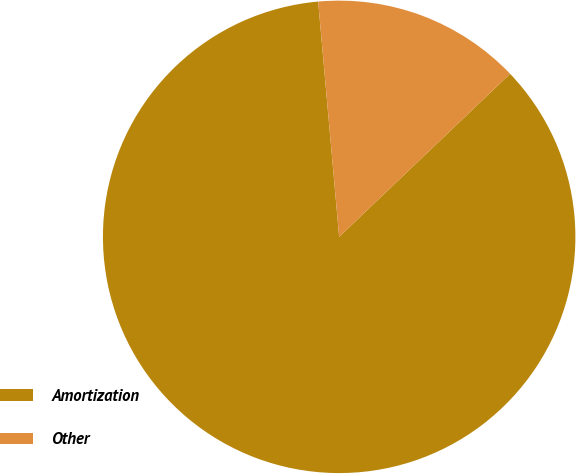<chart> <loc_0><loc_0><loc_500><loc_500><pie_chart><fcel>Amortization<fcel>Other<nl><fcel>85.71%<fcel>14.29%<nl></chart> 